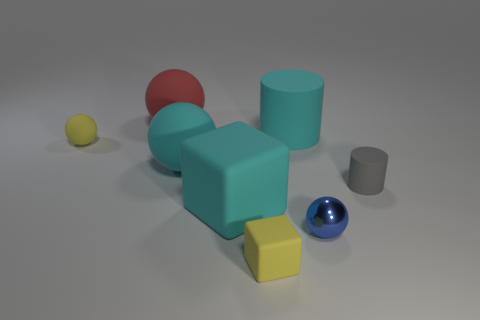What is the arrangement of the objects like and does it suggest anything about their relationship? The objects are arranged in a somewhat scattered manner across a neutral surface, with varying distances between them. This staggered positioning might suggest randomness or the absence of intentional organization, which can be indicative of a casual, unstructured environment. There doesn't seem to be a clear pattern or grouping that would imply a specific relationship amongst the objects; they could simply be a collection of unrelated items placed together for the purpose of the image. 